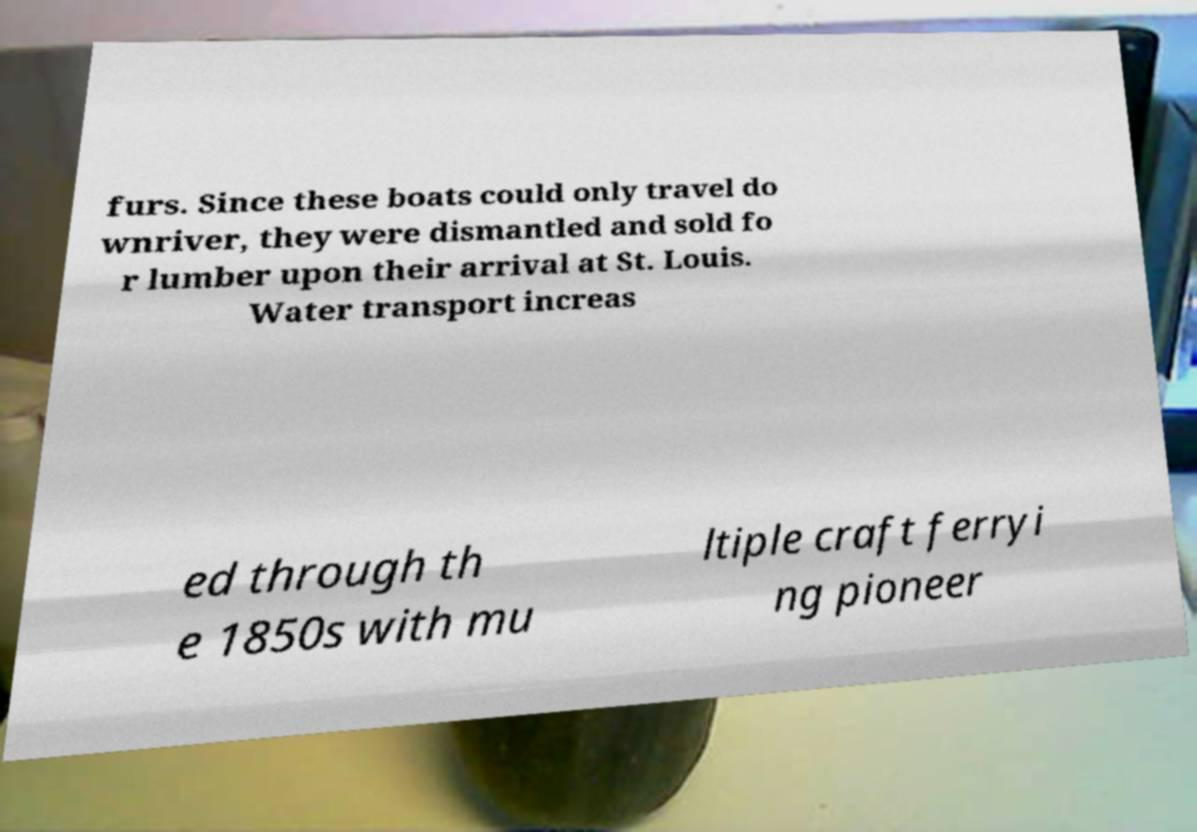Please read and relay the text visible in this image. What does it say? furs. Since these boats could only travel do wnriver, they were dismantled and sold fo r lumber upon their arrival at St. Louis. Water transport increas ed through th e 1850s with mu ltiple craft ferryi ng pioneer 